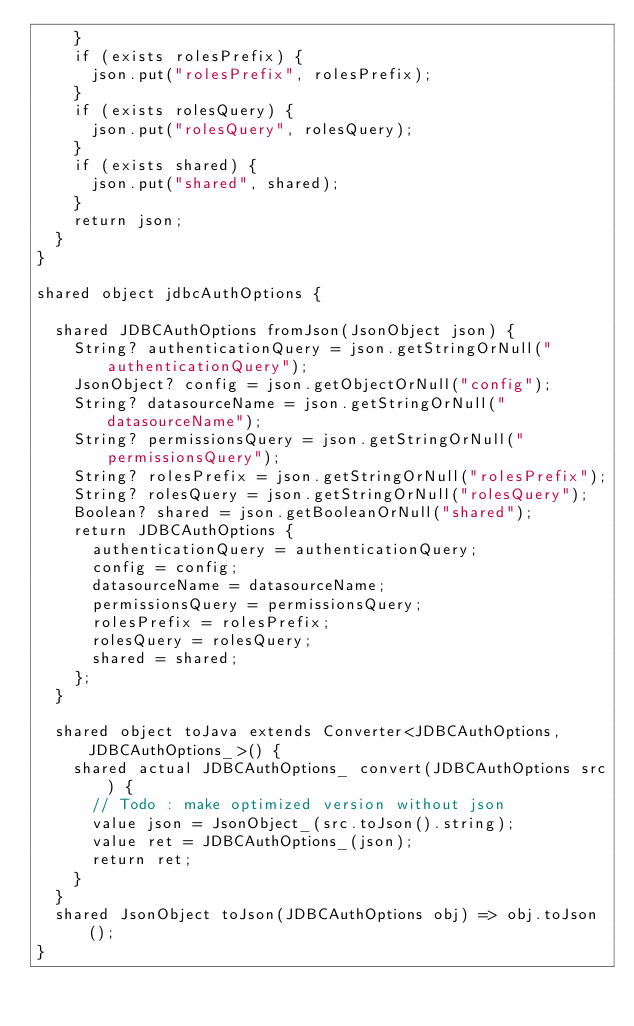Convert code to text. <code><loc_0><loc_0><loc_500><loc_500><_Ceylon_>    }
    if (exists rolesPrefix) {
      json.put("rolesPrefix", rolesPrefix);
    }
    if (exists rolesQuery) {
      json.put("rolesQuery", rolesQuery);
    }
    if (exists shared) {
      json.put("shared", shared);
    }
    return json;
  }
}

shared object jdbcAuthOptions {

  shared JDBCAuthOptions fromJson(JsonObject json) {
    String? authenticationQuery = json.getStringOrNull("authenticationQuery");
    JsonObject? config = json.getObjectOrNull("config");
    String? datasourceName = json.getStringOrNull("datasourceName");
    String? permissionsQuery = json.getStringOrNull("permissionsQuery");
    String? rolesPrefix = json.getStringOrNull("rolesPrefix");
    String? rolesQuery = json.getStringOrNull("rolesQuery");
    Boolean? shared = json.getBooleanOrNull("shared");
    return JDBCAuthOptions {
      authenticationQuery = authenticationQuery;
      config = config;
      datasourceName = datasourceName;
      permissionsQuery = permissionsQuery;
      rolesPrefix = rolesPrefix;
      rolesQuery = rolesQuery;
      shared = shared;
    };
  }

  shared object toJava extends Converter<JDBCAuthOptions, JDBCAuthOptions_>() {
    shared actual JDBCAuthOptions_ convert(JDBCAuthOptions src) {
      // Todo : make optimized version without json
      value json = JsonObject_(src.toJson().string);
      value ret = JDBCAuthOptions_(json);
      return ret;
    }
  }
  shared JsonObject toJson(JDBCAuthOptions obj) => obj.toJson();
}
</code> 